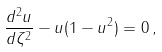Convert formula to latex. <formula><loc_0><loc_0><loc_500><loc_500>\frac { d ^ { 2 } u } { d \zeta ^ { 2 } } - u ( 1 - u ^ { 2 } ) = 0 \, ,</formula> 